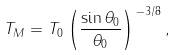<formula> <loc_0><loc_0><loc_500><loc_500>T _ { M } = T _ { 0 } \left ( \frac { \sin \theta _ { 0 } } { \theta _ { 0 } } \right ) ^ { \, - 3 / 8 } ,</formula> 